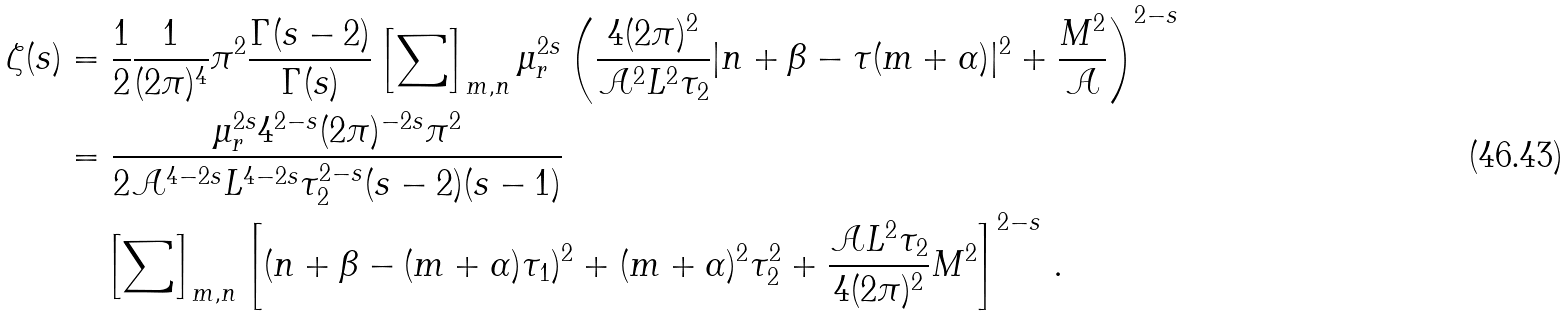Convert formula to latex. <formula><loc_0><loc_0><loc_500><loc_500>\zeta ( s ) & = \frac { 1 } { 2 } \frac { 1 } { ( 2 \pi ) ^ { 4 } } \pi ^ { 2 } \frac { \Gamma ( s - 2 ) } { \Gamma ( s ) } \left [ \sum \right ] _ { m , n } \mu _ { r } ^ { 2 s } \left ( \frac { 4 ( 2 \pi ) ^ { 2 } } { \mathcal { A } ^ { 2 } L ^ { 2 } \tau _ { 2 } } | n + \beta - \tau ( m + \alpha ) | ^ { 2 } + \frac { M ^ { 2 } } { \mathcal { A } } \right ) ^ { 2 - s } \\ & = \frac { \mu _ { r } ^ { 2 s } 4 ^ { 2 - s } ( 2 \pi ) ^ { - 2 s } \pi ^ { 2 } } { 2 \mathcal { A } ^ { 4 - 2 s } L ^ { 4 - 2 s } \tau _ { 2 } ^ { 2 - s } ( s - 2 ) ( s - 1 ) } \\ & \quad \left [ \sum \right ] _ { m , n } \left [ ( n + \beta - ( m + \alpha ) \tau _ { 1 } ) ^ { 2 } + ( m + \alpha ) ^ { 2 } \tau _ { 2 } ^ { 2 } + \frac { \mathcal { A } L ^ { 2 } \tau _ { 2 } } { 4 ( 2 \pi ) ^ { 2 } } M ^ { 2 } \right ] ^ { 2 - s } \, .</formula> 